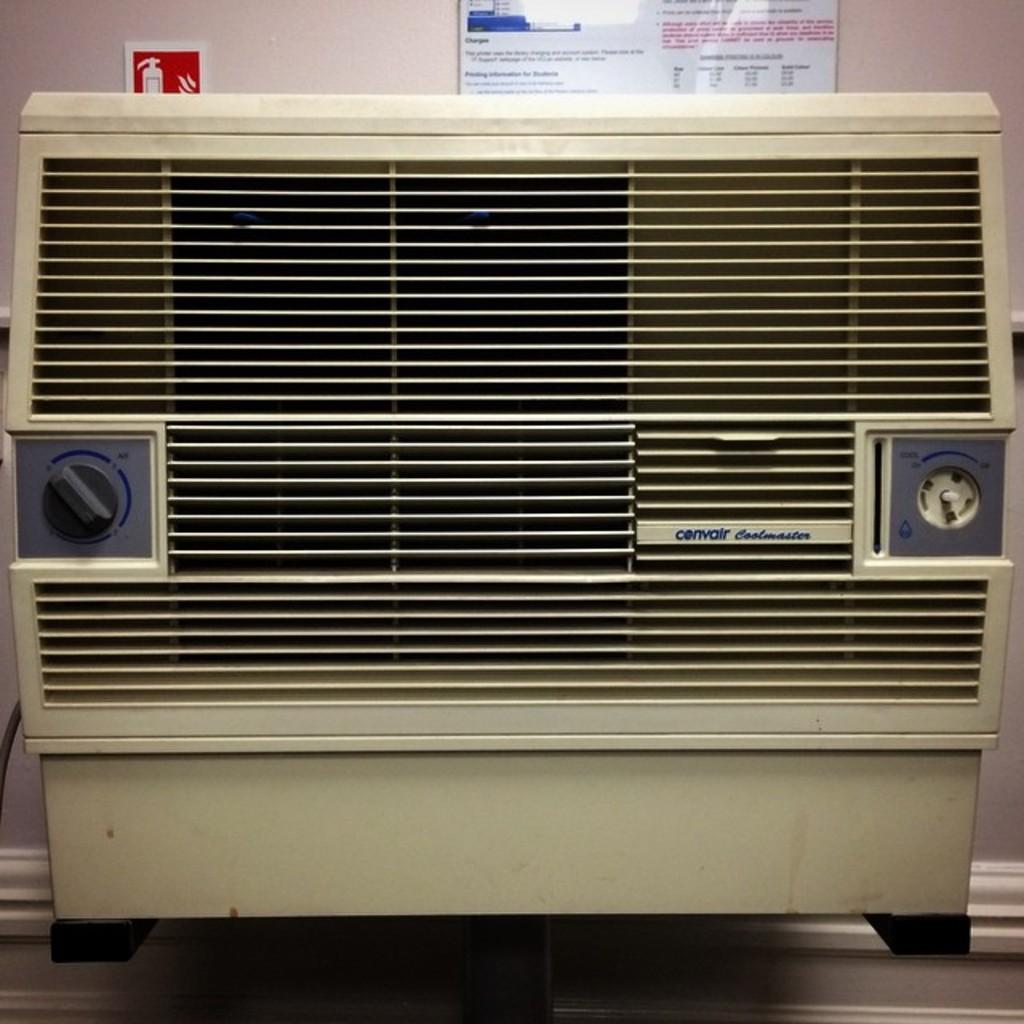What appliance can be seen in the image? There is an air conditioner in the picture. What is attached to the wall in the background of the image? There are boards attached to the wall in the background of the image. How many pencils are lying on the floor in the image? There are no pencils visible in the image. What type of waste can be seen in the image? There is no waste present in the image. 